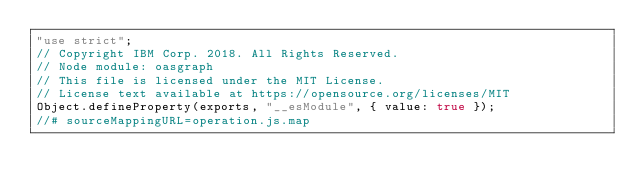<code> <loc_0><loc_0><loc_500><loc_500><_JavaScript_>"use strict";
// Copyright IBM Corp. 2018. All Rights Reserved.
// Node module: oasgraph
// This file is licensed under the MIT License.
// License text available at https://opensource.org/licenses/MIT
Object.defineProperty(exports, "__esModule", { value: true });
//# sourceMappingURL=operation.js.map</code> 